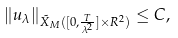<formula> <loc_0><loc_0><loc_500><loc_500>\| u _ { \lambda } \| _ { \tilde { X } _ { M } ( [ 0 , \frac { T } { \lambda ^ { 2 } } ] \times R ^ { 2 } ) } \leq C ,</formula> 